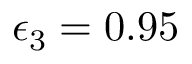<formula> <loc_0><loc_0><loc_500><loc_500>\epsilon _ { 3 } = 0 . 9 5</formula> 